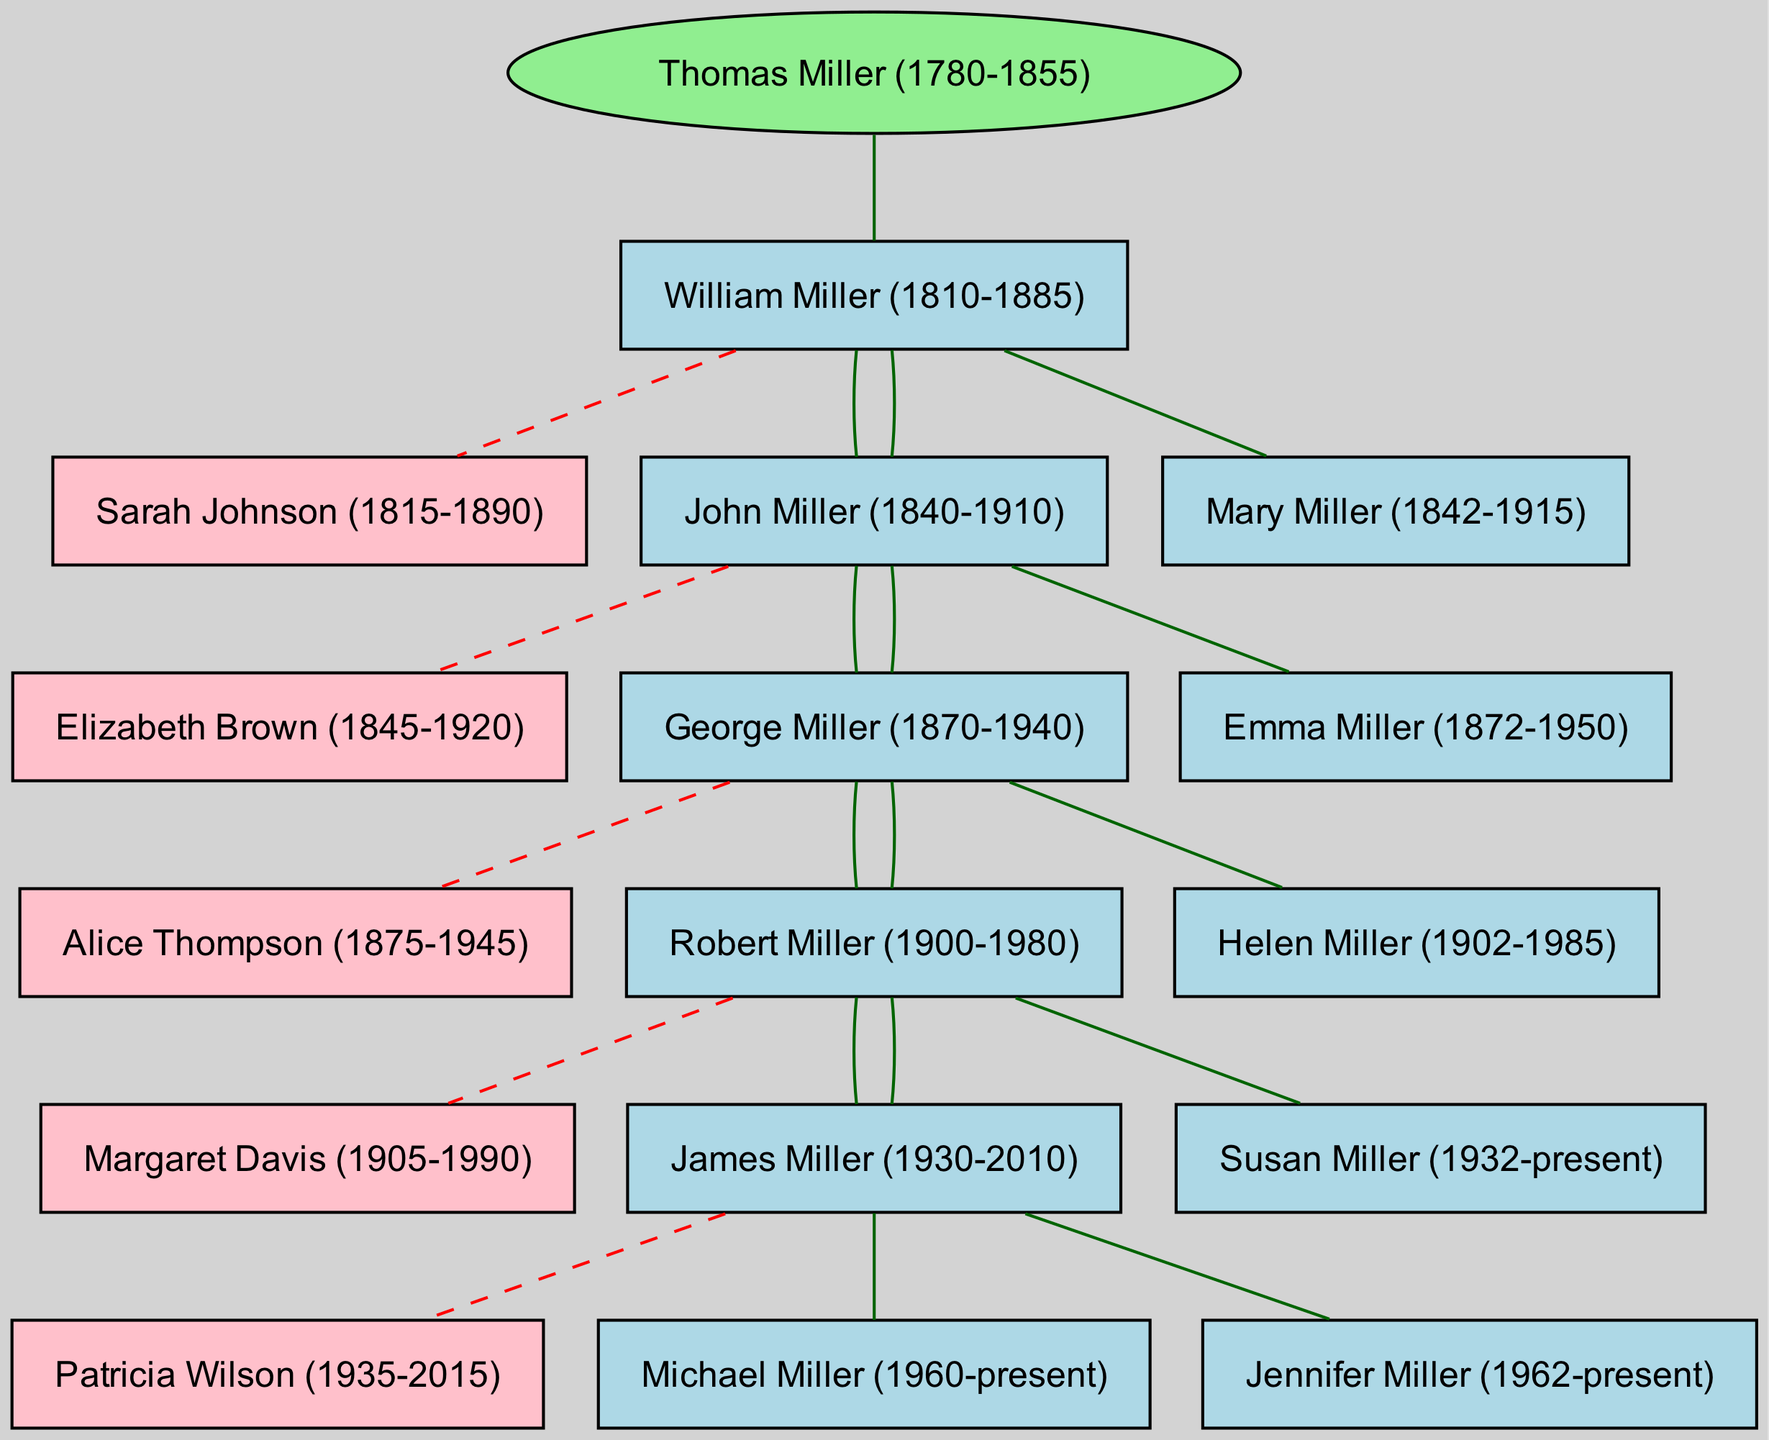What is the name of the root ancestor? The root ancestor is indicated at the top of the family tree, clearly labeled as "Thomas Miller (1780-1855)."
Answer: Thomas Miller (1780-1855) How many children did William Miller have? William Miller's children are listed under his name in the diagram, which shows two children: John Miller and Mary Miller.
Answer: 2 Who is the spouse of Robert Miller? Robert Miller’s spouse is shown connected by a dashed line, indicating their relationship. The name is "Margaret Davis (1905-1990)."
Answer: Margaret Davis (1905-1990) Which generation does George Miller belong to? By examining the diagram's structure, George Miller is seen listed as a child of John Miller, thus belonging to the second generation.
Answer: Second generation How many grandchildren does Thomas Miller have? Counting all the children of Thomas Miller's descendants, we note that John Miller has 2 children, George Miller has 2 children, and Robert Miller has 2 children, totaling 6 grandchildren.
Answer: 6 Who are the parents of Michael Miller? Michael Miller is listed as a child of James Miller and Patricia Wilson, both shown with a connection to him in the tree structure.
Answer: James Miller and Patricia Wilson What is the lifespan of Helen Miller? Helen Miller's lifespan is indicated next to her name as "1902-1985," providing clear year data for her life.
Answer: 1902-1985 How many generations are shown in the family tree? To determine the total generations, count each level in the family tree starting from Thomas Miller as generation one, William Miller as generation two, etc. The diagram reflects 5 generations.
Answer: 5 What type of connection is shown between spouses in the diagram? The connection between spouses is represented by dashed lines in the diagram, indicating a marital relationship between them.
Answer: Dashed line 